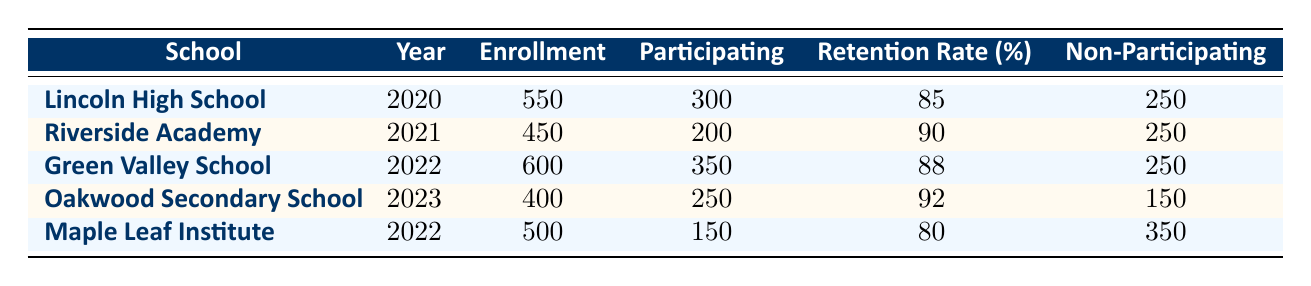What's the retention rate for Lincoln High School in 2020? The table shows that Lincoln High School has a retention rate of 85% in the year 2020.
Answer: 85% How many students participated in the character education program at Riverside Academy in 2021? The table indicates that Riverside Academy had 200 students participating in the character education program in 2021.
Answer: 200 Which school had the highest retention rate and what was it? Comparing the retention rates in the table, Oakwood Secondary School has the highest retention rate of 92% in 2023.
Answer: 92% What is the total enrollment for the schools listed in 2022? The total enrollment for the schools in 2022 is 600 (Green Valley School) + 500 (Maple Leaf Institute) = 1100.
Answer: 1100 Did Maple Leaf Institute have a higher or lower retention rate than Lincoln High School? Maple Leaf Institute had a retention rate of 80%, which is lower than Lincoln High School’s retention rate of 85%.
Answer: Lower What is the average retention rate for the schools listed in the table? To calculate the average retention rate, we add the individual rates: (85 + 90 + 88 + 92 + 80) = 435. Then divide by the number of schools (5): 435/5 = 87.
Answer: 87 How many students were not participating in the character education program at Green Valley School in 2022? The table states that Green Valley School had 250 non-participating students in 2022.
Answer: 250 Was there a significant difference in retention rates between the schools that implemented character education programs in 2020 and 2023? Comparing the retention rates, Lincoln High School in 2020 had 85%, and Oakwood Secondary School in 2023 had 92%. The difference is 92 - 85 = 7%, indicating an improvement.
Answer: Yes What character education program was implemented at Oakwood Secondary School, and was it associated with a high retention rate? The Oakwood Secondary School implemented the Leadership Development Program in 2023, which was associated with a high retention rate of 92%.
Answer: Yes 